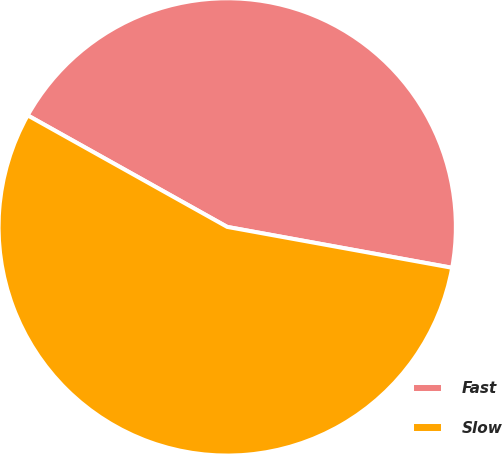Convert chart. <chart><loc_0><loc_0><loc_500><loc_500><pie_chart><fcel>Fast<fcel>Slow<nl><fcel>44.75%<fcel>55.25%<nl></chart> 